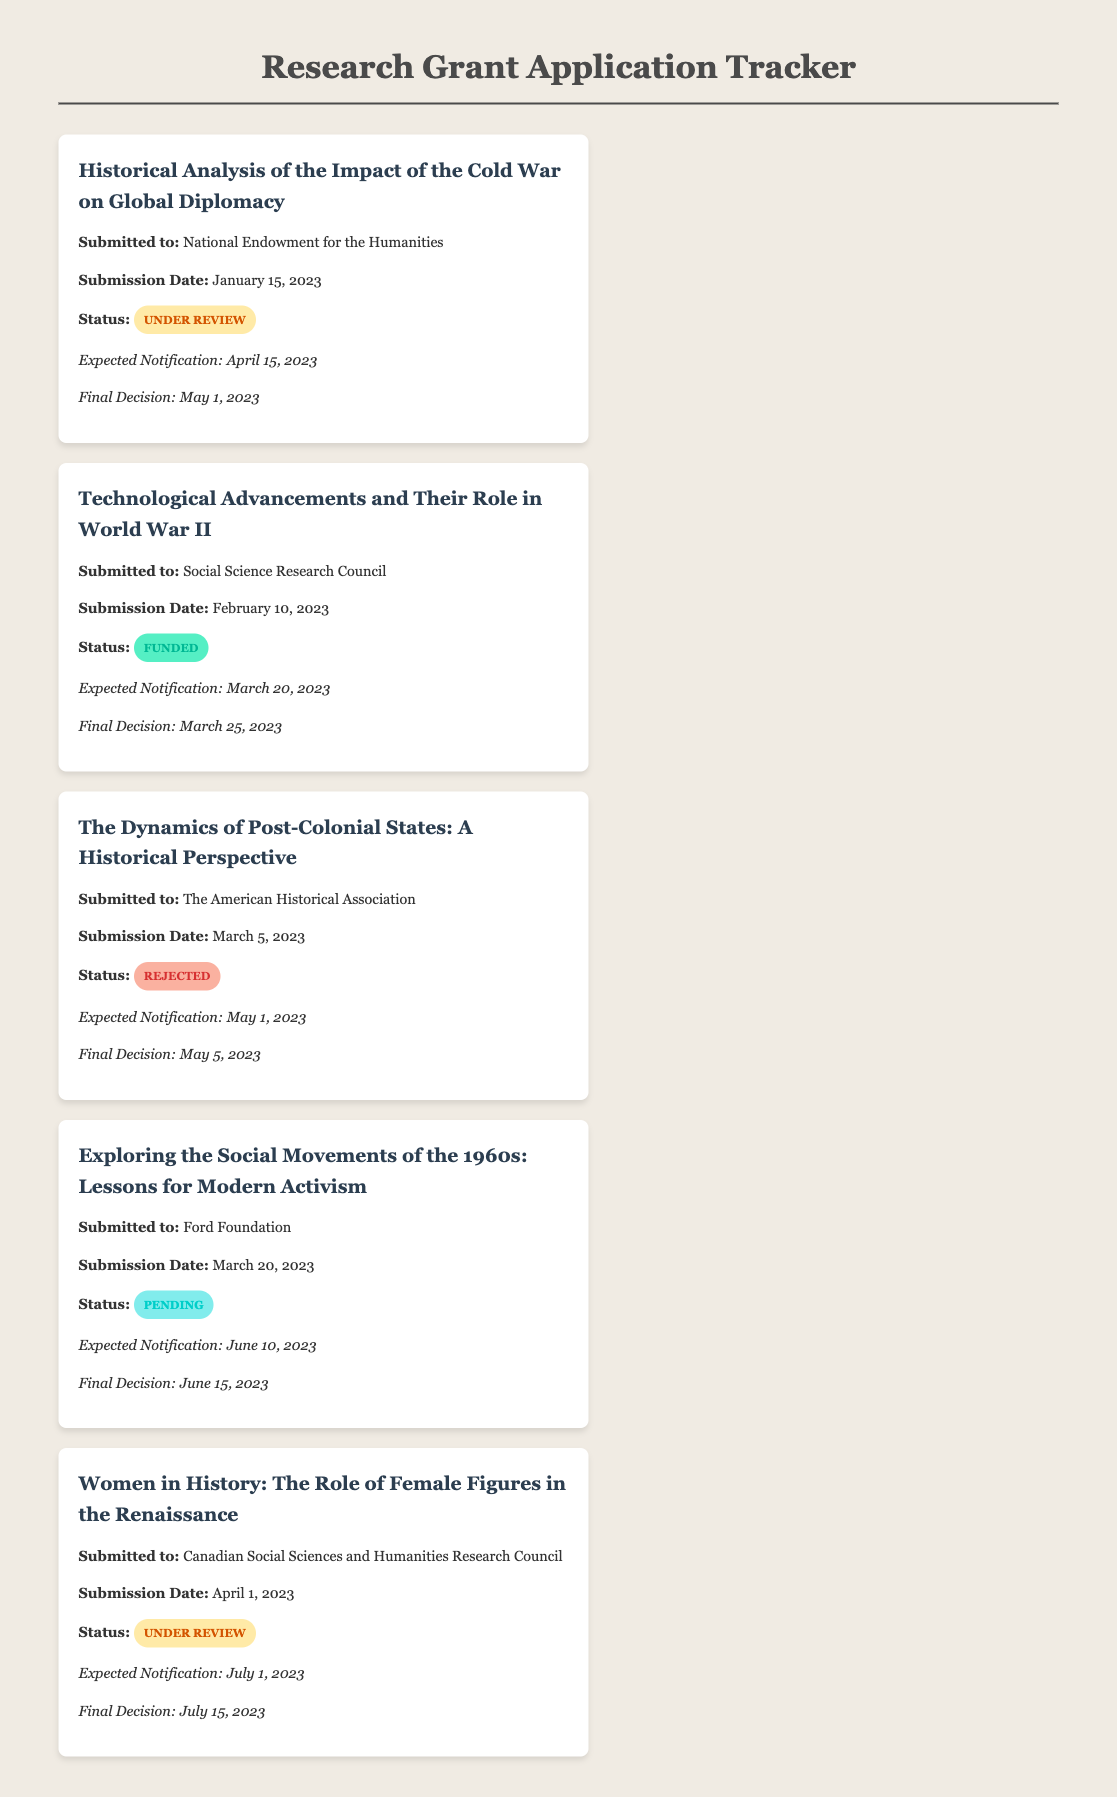What is the title of the first proposal? The title of the first proposal is specifically mentioned at the beginning of the corresponding card.
Answer: Historical Analysis of the Impact of the Cold War on Global Diplomacy Who funded the second proposal? The funding agency for the second proposal is clearly stated in the submission details.
Answer: Social Science Research Council What is the submission date of the fourth grant? The submission date can be found in the details provided within the fourth grant card.
Answer: March 20, 2023 What is the status of the third proposal? The status of the third proposal is categorized under the details section, indicating the outcome of the application.
Answer: Rejected When is the expected notification for the fifth proposal? The expected notification date is mentioned in the timeline section of the fifth grant card.
Answer: July 1, 2023 Which grant proposal has a pending status? The grant proposal with a pending status can be identified from the status section of the corresponding card.
Answer: Exploring the Social Movements of the 1960s: Lessons for Modern Activism What is the final decision date for the second grant? The final decision date is provided in the timeline for the second grant proposal, indicating when the decision will be made.
Answer: March 25, 2023 Which funding agency is related to the first proposal? The funding agency is explicitly mentioned in the details of the first grant proposal.
Answer: National Endowment for the Humanities 